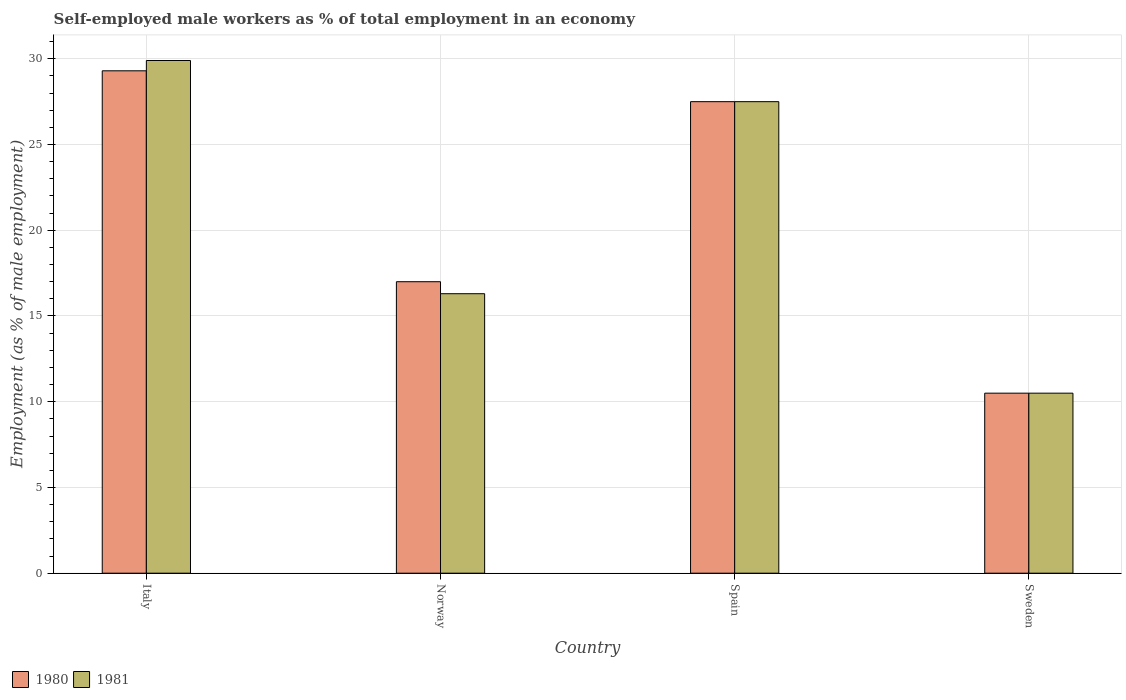How many bars are there on the 2nd tick from the left?
Your response must be concise. 2. What is the label of the 1st group of bars from the left?
Give a very brief answer. Italy. What is the percentage of self-employed male workers in 1981 in Sweden?
Offer a terse response. 10.5. Across all countries, what is the maximum percentage of self-employed male workers in 1981?
Make the answer very short. 29.9. In which country was the percentage of self-employed male workers in 1981 maximum?
Provide a short and direct response. Italy. In which country was the percentage of self-employed male workers in 1980 minimum?
Provide a short and direct response. Sweden. What is the total percentage of self-employed male workers in 1981 in the graph?
Provide a short and direct response. 84.2. What is the difference between the percentage of self-employed male workers in 1981 in Italy and that in Sweden?
Keep it short and to the point. 19.4. What is the difference between the percentage of self-employed male workers in 1980 in Sweden and the percentage of self-employed male workers in 1981 in Spain?
Offer a terse response. -17. What is the average percentage of self-employed male workers in 1981 per country?
Your answer should be compact. 21.05. What is the ratio of the percentage of self-employed male workers in 1980 in Italy to that in Norway?
Your answer should be compact. 1.72. Is the percentage of self-employed male workers in 1980 in Italy less than that in Norway?
Keep it short and to the point. No. What is the difference between the highest and the second highest percentage of self-employed male workers in 1981?
Give a very brief answer. -11.2. What is the difference between the highest and the lowest percentage of self-employed male workers in 1981?
Provide a short and direct response. 19.4. Is the sum of the percentage of self-employed male workers in 1981 in Norway and Sweden greater than the maximum percentage of self-employed male workers in 1980 across all countries?
Ensure brevity in your answer.  No. How many bars are there?
Provide a succinct answer. 8. Does the graph contain any zero values?
Give a very brief answer. No. Does the graph contain grids?
Offer a terse response. Yes. Where does the legend appear in the graph?
Ensure brevity in your answer.  Bottom left. What is the title of the graph?
Keep it short and to the point. Self-employed male workers as % of total employment in an economy. Does "1988" appear as one of the legend labels in the graph?
Make the answer very short. No. What is the label or title of the Y-axis?
Ensure brevity in your answer.  Employment (as % of male employment). What is the Employment (as % of male employment) of 1980 in Italy?
Offer a very short reply. 29.3. What is the Employment (as % of male employment) of 1981 in Italy?
Offer a very short reply. 29.9. What is the Employment (as % of male employment) of 1981 in Norway?
Ensure brevity in your answer.  16.3. What is the Employment (as % of male employment) in 1981 in Spain?
Your response must be concise. 27.5. What is the Employment (as % of male employment) of 1980 in Sweden?
Your answer should be very brief. 10.5. Across all countries, what is the maximum Employment (as % of male employment) of 1980?
Give a very brief answer. 29.3. Across all countries, what is the maximum Employment (as % of male employment) in 1981?
Make the answer very short. 29.9. Across all countries, what is the minimum Employment (as % of male employment) in 1980?
Offer a very short reply. 10.5. What is the total Employment (as % of male employment) in 1980 in the graph?
Provide a short and direct response. 84.3. What is the total Employment (as % of male employment) in 1981 in the graph?
Provide a succinct answer. 84.2. What is the difference between the Employment (as % of male employment) in 1980 in Italy and that in Norway?
Give a very brief answer. 12.3. What is the difference between the Employment (as % of male employment) in 1981 in Italy and that in Norway?
Offer a terse response. 13.6. What is the difference between the Employment (as % of male employment) in 1980 in Italy and that in Spain?
Give a very brief answer. 1.8. What is the difference between the Employment (as % of male employment) of 1981 in Italy and that in Sweden?
Make the answer very short. 19.4. What is the difference between the Employment (as % of male employment) of 1981 in Norway and that in Spain?
Ensure brevity in your answer.  -11.2. What is the difference between the Employment (as % of male employment) in 1980 in Norway and that in Sweden?
Provide a short and direct response. 6.5. What is the difference between the Employment (as % of male employment) of 1981 in Norway and that in Sweden?
Your answer should be very brief. 5.8. What is the difference between the Employment (as % of male employment) in 1980 in Spain and that in Sweden?
Make the answer very short. 17. What is the difference between the Employment (as % of male employment) in 1981 in Spain and that in Sweden?
Your answer should be very brief. 17. What is the difference between the Employment (as % of male employment) of 1980 in Italy and the Employment (as % of male employment) of 1981 in Norway?
Ensure brevity in your answer.  13. What is the difference between the Employment (as % of male employment) of 1980 in Italy and the Employment (as % of male employment) of 1981 in Spain?
Give a very brief answer. 1.8. What is the difference between the Employment (as % of male employment) of 1980 in Norway and the Employment (as % of male employment) of 1981 in Spain?
Offer a terse response. -10.5. What is the average Employment (as % of male employment) in 1980 per country?
Your answer should be very brief. 21.07. What is the average Employment (as % of male employment) in 1981 per country?
Ensure brevity in your answer.  21.05. What is the difference between the Employment (as % of male employment) in 1980 and Employment (as % of male employment) in 1981 in Italy?
Provide a short and direct response. -0.6. What is the difference between the Employment (as % of male employment) of 1980 and Employment (as % of male employment) of 1981 in Sweden?
Make the answer very short. 0. What is the ratio of the Employment (as % of male employment) in 1980 in Italy to that in Norway?
Offer a terse response. 1.72. What is the ratio of the Employment (as % of male employment) in 1981 in Italy to that in Norway?
Provide a succinct answer. 1.83. What is the ratio of the Employment (as % of male employment) in 1980 in Italy to that in Spain?
Your response must be concise. 1.07. What is the ratio of the Employment (as % of male employment) in 1981 in Italy to that in Spain?
Give a very brief answer. 1.09. What is the ratio of the Employment (as % of male employment) in 1980 in Italy to that in Sweden?
Your answer should be very brief. 2.79. What is the ratio of the Employment (as % of male employment) in 1981 in Italy to that in Sweden?
Ensure brevity in your answer.  2.85. What is the ratio of the Employment (as % of male employment) in 1980 in Norway to that in Spain?
Your answer should be compact. 0.62. What is the ratio of the Employment (as % of male employment) of 1981 in Norway to that in Spain?
Your answer should be very brief. 0.59. What is the ratio of the Employment (as % of male employment) of 1980 in Norway to that in Sweden?
Make the answer very short. 1.62. What is the ratio of the Employment (as % of male employment) of 1981 in Norway to that in Sweden?
Provide a short and direct response. 1.55. What is the ratio of the Employment (as % of male employment) of 1980 in Spain to that in Sweden?
Provide a succinct answer. 2.62. What is the ratio of the Employment (as % of male employment) of 1981 in Spain to that in Sweden?
Keep it short and to the point. 2.62. What is the difference between the highest and the second highest Employment (as % of male employment) in 1981?
Ensure brevity in your answer.  2.4. What is the difference between the highest and the lowest Employment (as % of male employment) of 1980?
Make the answer very short. 18.8. 